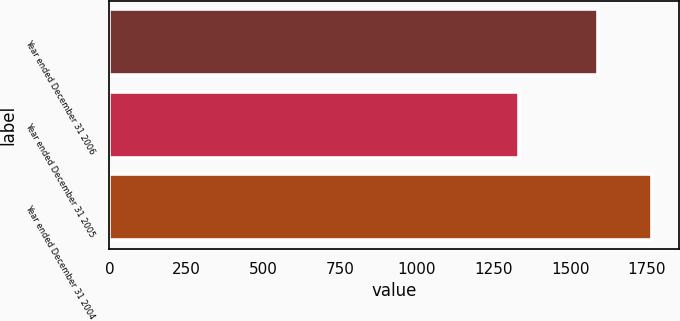<chart> <loc_0><loc_0><loc_500><loc_500><bar_chart><fcel>Year ended December 31 2006<fcel>Year ended December 31 2005<fcel>Year ended December 31 2004<nl><fcel>1591<fcel>1334<fcel>1765<nl></chart> 